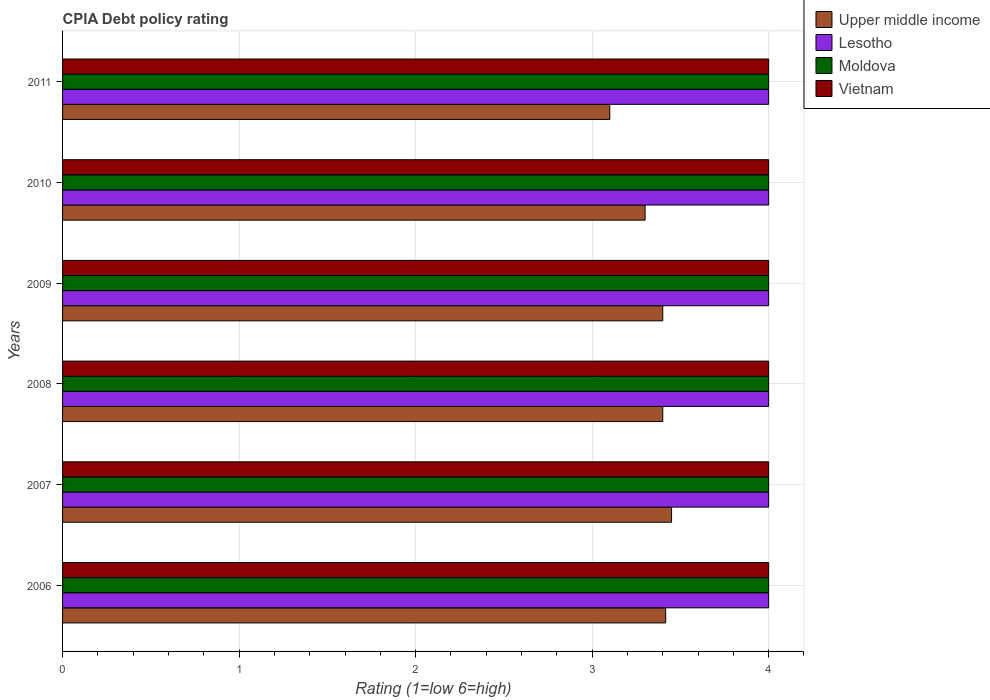How many different coloured bars are there?
Keep it short and to the point. 4. How many bars are there on the 3rd tick from the top?
Give a very brief answer. 4. What is the label of the 5th group of bars from the top?
Your answer should be very brief. 2007. In how many cases, is the number of bars for a given year not equal to the number of legend labels?
Ensure brevity in your answer.  0. What is the CPIA rating in Vietnam in 2008?
Offer a terse response. 4. Across all years, what is the maximum CPIA rating in Vietnam?
Offer a terse response. 4. Across all years, what is the minimum CPIA rating in Moldova?
Keep it short and to the point. 4. In which year was the CPIA rating in Moldova maximum?
Ensure brevity in your answer.  2006. In which year was the CPIA rating in Lesotho minimum?
Give a very brief answer. 2006. What is the total CPIA rating in Moldova in the graph?
Offer a terse response. 24. What is the difference between the CPIA rating in Moldova in 2007 and that in 2008?
Provide a short and direct response. 0. What is the average CPIA rating in Upper middle income per year?
Ensure brevity in your answer.  3.34. In the year 2007, what is the difference between the CPIA rating in Moldova and CPIA rating in Vietnam?
Your response must be concise. 0. In how many years, is the CPIA rating in Upper middle income greater than 1.6 ?
Give a very brief answer. 6. What is the ratio of the CPIA rating in Vietnam in 2008 to that in 2010?
Ensure brevity in your answer.  1. What is the difference between the highest and the second highest CPIA rating in Lesotho?
Make the answer very short. 0. What is the difference between the highest and the lowest CPIA rating in Upper middle income?
Make the answer very short. 0.35. In how many years, is the CPIA rating in Vietnam greater than the average CPIA rating in Vietnam taken over all years?
Give a very brief answer. 0. Is it the case that in every year, the sum of the CPIA rating in Lesotho and CPIA rating in Upper middle income is greater than the sum of CPIA rating in Moldova and CPIA rating in Vietnam?
Offer a terse response. No. What does the 2nd bar from the top in 2008 represents?
Your answer should be compact. Moldova. What does the 4th bar from the bottom in 2009 represents?
Provide a succinct answer. Vietnam. Does the graph contain grids?
Your answer should be very brief. Yes. How many legend labels are there?
Offer a terse response. 4. What is the title of the graph?
Offer a terse response. CPIA Debt policy rating. Does "Heavily indebted poor countries" appear as one of the legend labels in the graph?
Your answer should be compact. No. What is the label or title of the X-axis?
Your answer should be very brief. Rating (1=low 6=high). What is the Rating (1=low 6=high) in Upper middle income in 2006?
Ensure brevity in your answer.  3.42. What is the Rating (1=low 6=high) in Moldova in 2006?
Provide a succinct answer. 4. What is the Rating (1=low 6=high) in Upper middle income in 2007?
Your answer should be compact. 3.45. What is the Rating (1=low 6=high) of Lesotho in 2007?
Offer a terse response. 4. What is the Rating (1=low 6=high) of Lesotho in 2008?
Offer a terse response. 4. What is the Rating (1=low 6=high) in Moldova in 2009?
Ensure brevity in your answer.  4. What is the Rating (1=low 6=high) of Lesotho in 2010?
Offer a very short reply. 4. What is the Rating (1=low 6=high) of Vietnam in 2010?
Your answer should be compact. 4. What is the Rating (1=low 6=high) in Upper middle income in 2011?
Ensure brevity in your answer.  3.1. What is the Rating (1=low 6=high) in Moldova in 2011?
Give a very brief answer. 4. Across all years, what is the maximum Rating (1=low 6=high) of Upper middle income?
Your answer should be compact. 3.45. Across all years, what is the maximum Rating (1=low 6=high) of Vietnam?
Make the answer very short. 4. Across all years, what is the minimum Rating (1=low 6=high) of Upper middle income?
Offer a very short reply. 3.1. Across all years, what is the minimum Rating (1=low 6=high) of Moldova?
Your answer should be very brief. 4. Across all years, what is the minimum Rating (1=low 6=high) of Vietnam?
Offer a very short reply. 4. What is the total Rating (1=low 6=high) in Upper middle income in the graph?
Offer a terse response. 20.07. What is the total Rating (1=low 6=high) of Moldova in the graph?
Your response must be concise. 24. What is the total Rating (1=low 6=high) in Vietnam in the graph?
Offer a very short reply. 24. What is the difference between the Rating (1=low 6=high) of Upper middle income in 2006 and that in 2007?
Offer a terse response. -0.03. What is the difference between the Rating (1=low 6=high) in Lesotho in 2006 and that in 2007?
Keep it short and to the point. 0. What is the difference between the Rating (1=low 6=high) of Moldova in 2006 and that in 2007?
Offer a very short reply. 0. What is the difference between the Rating (1=low 6=high) of Upper middle income in 2006 and that in 2008?
Provide a succinct answer. 0.02. What is the difference between the Rating (1=low 6=high) in Lesotho in 2006 and that in 2008?
Offer a terse response. 0. What is the difference between the Rating (1=low 6=high) of Upper middle income in 2006 and that in 2009?
Your answer should be compact. 0.02. What is the difference between the Rating (1=low 6=high) in Lesotho in 2006 and that in 2009?
Provide a short and direct response. 0. What is the difference between the Rating (1=low 6=high) in Moldova in 2006 and that in 2009?
Ensure brevity in your answer.  0. What is the difference between the Rating (1=low 6=high) of Upper middle income in 2006 and that in 2010?
Make the answer very short. 0.12. What is the difference between the Rating (1=low 6=high) in Lesotho in 2006 and that in 2010?
Give a very brief answer. 0. What is the difference between the Rating (1=low 6=high) of Upper middle income in 2006 and that in 2011?
Provide a succinct answer. 0.32. What is the difference between the Rating (1=low 6=high) of Lesotho in 2006 and that in 2011?
Make the answer very short. 0. What is the difference between the Rating (1=low 6=high) in Upper middle income in 2007 and that in 2008?
Make the answer very short. 0.05. What is the difference between the Rating (1=low 6=high) in Lesotho in 2007 and that in 2008?
Your response must be concise. 0. What is the difference between the Rating (1=low 6=high) of Vietnam in 2007 and that in 2008?
Ensure brevity in your answer.  0. What is the difference between the Rating (1=low 6=high) of Upper middle income in 2007 and that in 2009?
Offer a very short reply. 0.05. What is the difference between the Rating (1=low 6=high) in Vietnam in 2007 and that in 2010?
Offer a terse response. 0. What is the difference between the Rating (1=low 6=high) in Moldova in 2007 and that in 2011?
Offer a very short reply. 0. What is the difference between the Rating (1=low 6=high) in Upper middle income in 2008 and that in 2009?
Ensure brevity in your answer.  0. What is the difference between the Rating (1=low 6=high) in Lesotho in 2008 and that in 2009?
Give a very brief answer. 0. What is the difference between the Rating (1=low 6=high) in Moldova in 2008 and that in 2009?
Your answer should be very brief. 0. What is the difference between the Rating (1=low 6=high) in Vietnam in 2008 and that in 2009?
Offer a very short reply. 0. What is the difference between the Rating (1=low 6=high) in Upper middle income in 2008 and that in 2010?
Give a very brief answer. 0.1. What is the difference between the Rating (1=low 6=high) in Lesotho in 2008 and that in 2010?
Your response must be concise. 0. What is the difference between the Rating (1=low 6=high) of Vietnam in 2008 and that in 2010?
Give a very brief answer. 0. What is the difference between the Rating (1=low 6=high) of Lesotho in 2008 and that in 2011?
Ensure brevity in your answer.  0. What is the difference between the Rating (1=low 6=high) of Upper middle income in 2009 and that in 2010?
Keep it short and to the point. 0.1. What is the difference between the Rating (1=low 6=high) of Lesotho in 2009 and that in 2011?
Make the answer very short. 0. What is the difference between the Rating (1=low 6=high) of Moldova in 2009 and that in 2011?
Provide a succinct answer. 0. What is the difference between the Rating (1=low 6=high) of Upper middle income in 2010 and that in 2011?
Offer a terse response. 0.2. What is the difference between the Rating (1=low 6=high) in Lesotho in 2010 and that in 2011?
Offer a very short reply. 0. What is the difference between the Rating (1=low 6=high) of Moldova in 2010 and that in 2011?
Your answer should be compact. 0. What is the difference between the Rating (1=low 6=high) of Vietnam in 2010 and that in 2011?
Make the answer very short. 0. What is the difference between the Rating (1=low 6=high) in Upper middle income in 2006 and the Rating (1=low 6=high) in Lesotho in 2007?
Keep it short and to the point. -0.58. What is the difference between the Rating (1=low 6=high) of Upper middle income in 2006 and the Rating (1=low 6=high) of Moldova in 2007?
Offer a very short reply. -0.58. What is the difference between the Rating (1=low 6=high) in Upper middle income in 2006 and the Rating (1=low 6=high) in Vietnam in 2007?
Give a very brief answer. -0.58. What is the difference between the Rating (1=low 6=high) in Lesotho in 2006 and the Rating (1=low 6=high) in Moldova in 2007?
Your answer should be compact. 0. What is the difference between the Rating (1=low 6=high) of Lesotho in 2006 and the Rating (1=low 6=high) of Vietnam in 2007?
Your answer should be very brief. 0. What is the difference between the Rating (1=low 6=high) in Upper middle income in 2006 and the Rating (1=low 6=high) in Lesotho in 2008?
Your response must be concise. -0.58. What is the difference between the Rating (1=low 6=high) in Upper middle income in 2006 and the Rating (1=low 6=high) in Moldova in 2008?
Your response must be concise. -0.58. What is the difference between the Rating (1=low 6=high) of Upper middle income in 2006 and the Rating (1=low 6=high) of Vietnam in 2008?
Your answer should be very brief. -0.58. What is the difference between the Rating (1=low 6=high) in Upper middle income in 2006 and the Rating (1=low 6=high) in Lesotho in 2009?
Provide a short and direct response. -0.58. What is the difference between the Rating (1=low 6=high) of Upper middle income in 2006 and the Rating (1=low 6=high) of Moldova in 2009?
Offer a very short reply. -0.58. What is the difference between the Rating (1=low 6=high) of Upper middle income in 2006 and the Rating (1=low 6=high) of Vietnam in 2009?
Give a very brief answer. -0.58. What is the difference between the Rating (1=low 6=high) of Upper middle income in 2006 and the Rating (1=low 6=high) of Lesotho in 2010?
Your response must be concise. -0.58. What is the difference between the Rating (1=low 6=high) of Upper middle income in 2006 and the Rating (1=low 6=high) of Moldova in 2010?
Your response must be concise. -0.58. What is the difference between the Rating (1=low 6=high) of Upper middle income in 2006 and the Rating (1=low 6=high) of Vietnam in 2010?
Give a very brief answer. -0.58. What is the difference between the Rating (1=low 6=high) of Moldova in 2006 and the Rating (1=low 6=high) of Vietnam in 2010?
Make the answer very short. 0. What is the difference between the Rating (1=low 6=high) of Upper middle income in 2006 and the Rating (1=low 6=high) of Lesotho in 2011?
Offer a very short reply. -0.58. What is the difference between the Rating (1=low 6=high) of Upper middle income in 2006 and the Rating (1=low 6=high) of Moldova in 2011?
Offer a terse response. -0.58. What is the difference between the Rating (1=low 6=high) in Upper middle income in 2006 and the Rating (1=low 6=high) in Vietnam in 2011?
Your response must be concise. -0.58. What is the difference between the Rating (1=low 6=high) in Lesotho in 2006 and the Rating (1=low 6=high) in Moldova in 2011?
Your answer should be compact. 0. What is the difference between the Rating (1=low 6=high) of Lesotho in 2006 and the Rating (1=low 6=high) of Vietnam in 2011?
Make the answer very short. 0. What is the difference between the Rating (1=low 6=high) of Moldova in 2006 and the Rating (1=low 6=high) of Vietnam in 2011?
Keep it short and to the point. 0. What is the difference between the Rating (1=low 6=high) of Upper middle income in 2007 and the Rating (1=low 6=high) of Lesotho in 2008?
Provide a short and direct response. -0.55. What is the difference between the Rating (1=low 6=high) in Upper middle income in 2007 and the Rating (1=low 6=high) in Moldova in 2008?
Your response must be concise. -0.55. What is the difference between the Rating (1=low 6=high) in Upper middle income in 2007 and the Rating (1=low 6=high) in Vietnam in 2008?
Ensure brevity in your answer.  -0.55. What is the difference between the Rating (1=low 6=high) of Upper middle income in 2007 and the Rating (1=low 6=high) of Lesotho in 2009?
Your answer should be very brief. -0.55. What is the difference between the Rating (1=low 6=high) in Upper middle income in 2007 and the Rating (1=low 6=high) in Moldova in 2009?
Provide a succinct answer. -0.55. What is the difference between the Rating (1=low 6=high) in Upper middle income in 2007 and the Rating (1=low 6=high) in Vietnam in 2009?
Keep it short and to the point. -0.55. What is the difference between the Rating (1=low 6=high) of Moldova in 2007 and the Rating (1=low 6=high) of Vietnam in 2009?
Provide a succinct answer. 0. What is the difference between the Rating (1=low 6=high) in Upper middle income in 2007 and the Rating (1=low 6=high) in Lesotho in 2010?
Offer a terse response. -0.55. What is the difference between the Rating (1=low 6=high) of Upper middle income in 2007 and the Rating (1=low 6=high) of Moldova in 2010?
Make the answer very short. -0.55. What is the difference between the Rating (1=low 6=high) of Upper middle income in 2007 and the Rating (1=low 6=high) of Vietnam in 2010?
Keep it short and to the point. -0.55. What is the difference between the Rating (1=low 6=high) in Upper middle income in 2007 and the Rating (1=low 6=high) in Lesotho in 2011?
Your response must be concise. -0.55. What is the difference between the Rating (1=low 6=high) in Upper middle income in 2007 and the Rating (1=low 6=high) in Moldova in 2011?
Provide a succinct answer. -0.55. What is the difference between the Rating (1=low 6=high) in Upper middle income in 2007 and the Rating (1=low 6=high) in Vietnam in 2011?
Your answer should be very brief. -0.55. What is the difference between the Rating (1=low 6=high) in Lesotho in 2007 and the Rating (1=low 6=high) in Moldova in 2011?
Keep it short and to the point. 0. What is the difference between the Rating (1=low 6=high) of Upper middle income in 2008 and the Rating (1=low 6=high) of Moldova in 2009?
Keep it short and to the point. -0.6. What is the difference between the Rating (1=low 6=high) of Upper middle income in 2008 and the Rating (1=low 6=high) of Vietnam in 2009?
Offer a very short reply. -0.6. What is the difference between the Rating (1=low 6=high) of Lesotho in 2008 and the Rating (1=low 6=high) of Moldova in 2009?
Provide a short and direct response. 0. What is the difference between the Rating (1=low 6=high) in Upper middle income in 2008 and the Rating (1=low 6=high) in Moldova in 2010?
Give a very brief answer. -0.6. What is the difference between the Rating (1=low 6=high) in Lesotho in 2008 and the Rating (1=low 6=high) in Moldova in 2010?
Give a very brief answer. 0. What is the difference between the Rating (1=low 6=high) of Lesotho in 2008 and the Rating (1=low 6=high) of Vietnam in 2010?
Keep it short and to the point. 0. What is the difference between the Rating (1=low 6=high) of Upper middle income in 2008 and the Rating (1=low 6=high) of Moldova in 2011?
Ensure brevity in your answer.  -0.6. What is the difference between the Rating (1=low 6=high) of Upper middle income in 2008 and the Rating (1=low 6=high) of Vietnam in 2011?
Your response must be concise. -0.6. What is the difference between the Rating (1=low 6=high) of Lesotho in 2008 and the Rating (1=low 6=high) of Moldova in 2011?
Make the answer very short. 0. What is the difference between the Rating (1=low 6=high) in Lesotho in 2008 and the Rating (1=low 6=high) in Vietnam in 2011?
Your answer should be very brief. 0. What is the difference between the Rating (1=low 6=high) of Upper middle income in 2009 and the Rating (1=low 6=high) of Vietnam in 2010?
Your response must be concise. -0.6. What is the difference between the Rating (1=low 6=high) in Lesotho in 2009 and the Rating (1=low 6=high) in Moldova in 2010?
Offer a very short reply. 0. What is the difference between the Rating (1=low 6=high) in Lesotho in 2009 and the Rating (1=low 6=high) in Vietnam in 2010?
Your response must be concise. 0. What is the difference between the Rating (1=low 6=high) of Moldova in 2009 and the Rating (1=low 6=high) of Vietnam in 2010?
Ensure brevity in your answer.  0. What is the difference between the Rating (1=low 6=high) in Upper middle income in 2009 and the Rating (1=low 6=high) in Vietnam in 2011?
Ensure brevity in your answer.  -0.6. What is the difference between the Rating (1=low 6=high) in Lesotho in 2009 and the Rating (1=low 6=high) in Moldova in 2011?
Make the answer very short. 0. What is the difference between the Rating (1=low 6=high) of Moldova in 2009 and the Rating (1=low 6=high) of Vietnam in 2011?
Offer a terse response. 0. What is the difference between the Rating (1=low 6=high) of Lesotho in 2010 and the Rating (1=low 6=high) of Vietnam in 2011?
Give a very brief answer. 0. What is the average Rating (1=low 6=high) in Upper middle income per year?
Offer a terse response. 3.34. What is the average Rating (1=low 6=high) of Moldova per year?
Make the answer very short. 4. What is the average Rating (1=low 6=high) of Vietnam per year?
Ensure brevity in your answer.  4. In the year 2006, what is the difference between the Rating (1=low 6=high) in Upper middle income and Rating (1=low 6=high) in Lesotho?
Offer a terse response. -0.58. In the year 2006, what is the difference between the Rating (1=low 6=high) of Upper middle income and Rating (1=low 6=high) of Moldova?
Your response must be concise. -0.58. In the year 2006, what is the difference between the Rating (1=low 6=high) in Upper middle income and Rating (1=low 6=high) in Vietnam?
Offer a terse response. -0.58. In the year 2006, what is the difference between the Rating (1=low 6=high) of Lesotho and Rating (1=low 6=high) of Moldova?
Offer a very short reply. 0. In the year 2007, what is the difference between the Rating (1=low 6=high) of Upper middle income and Rating (1=low 6=high) of Lesotho?
Provide a succinct answer. -0.55. In the year 2007, what is the difference between the Rating (1=low 6=high) of Upper middle income and Rating (1=low 6=high) of Moldova?
Provide a short and direct response. -0.55. In the year 2007, what is the difference between the Rating (1=low 6=high) of Upper middle income and Rating (1=low 6=high) of Vietnam?
Keep it short and to the point. -0.55. In the year 2008, what is the difference between the Rating (1=low 6=high) of Upper middle income and Rating (1=low 6=high) of Lesotho?
Offer a terse response. -0.6. In the year 2008, what is the difference between the Rating (1=low 6=high) of Upper middle income and Rating (1=low 6=high) of Vietnam?
Make the answer very short. -0.6. In the year 2008, what is the difference between the Rating (1=low 6=high) of Lesotho and Rating (1=low 6=high) of Vietnam?
Offer a terse response. 0. In the year 2008, what is the difference between the Rating (1=low 6=high) in Moldova and Rating (1=low 6=high) in Vietnam?
Provide a short and direct response. 0. In the year 2009, what is the difference between the Rating (1=low 6=high) in Lesotho and Rating (1=low 6=high) in Moldova?
Ensure brevity in your answer.  0. In the year 2010, what is the difference between the Rating (1=low 6=high) of Moldova and Rating (1=low 6=high) of Vietnam?
Your answer should be compact. 0. In the year 2011, what is the difference between the Rating (1=low 6=high) in Upper middle income and Rating (1=low 6=high) in Lesotho?
Make the answer very short. -0.9. In the year 2011, what is the difference between the Rating (1=low 6=high) of Upper middle income and Rating (1=low 6=high) of Moldova?
Provide a succinct answer. -0.9. In the year 2011, what is the difference between the Rating (1=low 6=high) in Upper middle income and Rating (1=low 6=high) in Vietnam?
Your response must be concise. -0.9. In the year 2011, what is the difference between the Rating (1=low 6=high) of Lesotho and Rating (1=low 6=high) of Moldova?
Your response must be concise. 0. What is the ratio of the Rating (1=low 6=high) in Upper middle income in 2006 to that in 2007?
Ensure brevity in your answer.  0.99. What is the ratio of the Rating (1=low 6=high) in Lesotho in 2006 to that in 2007?
Your answer should be very brief. 1. What is the ratio of the Rating (1=low 6=high) of Moldova in 2006 to that in 2007?
Your response must be concise. 1. What is the ratio of the Rating (1=low 6=high) of Vietnam in 2006 to that in 2007?
Give a very brief answer. 1. What is the ratio of the Rating (1=low 6=high) in Upper middle income in 2006 to that in 2008?
Your response must be concise. 1. What is the ratio of the Rating (1=low 6=high) in Moldova in 2006 to that in 2009?
Provide a short and direct response. 1. What is the ratio of the Rating (1=low 6=high) in Vietnam in 2006 to that in 2009?
Give a very brief answer. 1. What is the ratio of the Rating (1=low 6=high) in Upper middle income in 2006 to that in 2010?
Your answer should be very brief. 1.04. What is the ratio of the Rating (1=low 6=high) in Moldova in 2006 to that in 2010?
Provide a short and direct response. 1. What is the ratio of the Rating (1=low 6=high) of Upper middle income in 2006 to that in 2011?
Your response must be concise. 1.1. What is the ratio of the Rating (1=low 6=high) of Upper middle income in 2007 to that in 2008?
Give a very brief answer. 1.01. What is the ratio of the Rating (1=low 6=high) of Moldova in 2007 to that in 2008?
Keep it short and to the point. 1. What is the ratio of the Rating (1=low 6=high) of Vietnam in 2007 to that in 2008?
Offer a terse response. 1. What is the ratio of the Rating (1=low 6=high) in Upper middle income in 2007 to that in 2009?
Make the answer very short. 1.01. What is the ratio of the Rating (1=low 6=high) in Lesotho in 2007 to that in 2009?
Provide a succinct answer. 1. What is the ratio of the Rating (1=low 6=high) in Moldova in 2007 to that in 2009?
Your answer should be compact. 1. What is the ratio of the Rating (1=low 6=high) of Vietnam in 2007 to that in 2009?
Your response must be concise. 1. What is the ratio of the Rating (1=low 6=high) of Upper middle income in 2007 to that in 2010?
Your response must be concise. 1.05. What is the ratio of the Rating (1=low 6=high) in Moldova in 2007 to that in 2010?
Your answer should be very brief. 1. What is the ratio of the Rating (1=low 6=high) of Upper middle income in 2007 to that in 2011?
Make the answer very short. 1.11. What is the ratio of the Rating (1=low 6=high) in Moldova in 2007 to that in 2011?
Provide a short and direct response. 1. What is the ratio of the Rating (1=low 6=high) of Vietnam in 2007 to that in 2011?
Ensure brevity in your answer.  1. What is the ratio of the Rating (1=low 6=high) of Upper middle income in 2008 to that in 2009?
Your answer should be very brief. 1. What is the ratio of the Rating (1=low 6=high) in Upper middle income in 2008 to that in 2010?
Offer a terse response. 1.03. What is the ratio of the Rating (1=low 6=high) in Lesotho in 2008 to that in 2010?
Make the answer very short. 1. What is the ratio of the Rating (1=low 6=high) in Moldova in 2008 to that in 2010?
Keep it short and to the point. 1. What is the ratio of the Rating (1=low 6=high) in Vietnam in 2008 to that in 2010?
Provide a succinct answer. 1. What is the ratio of the Rating (1=low 6=high) in Upper middle income in 2008 to that in 2011?
Provide a short and direct response. 1.1. What is the ratio of the Rating (1=low 6=high) in Lesotho in 2008 to that in 2011?
Offer a very short reply. 1. What is the ratio of the Rating (1=low 6=high) of Vietnam in 2008 to that in 2011?
Your response must be concise. 1. What is the ratio of the Rating (1=low 6=high) in Upper middle income in 2009 to that in 2010?
Offer a very short reply. 1.03. What is the ratio of the Rating (1=low 6=high) in Moldova in 2009 to that in 2010?
Your response must be concise. 1. What is the ratio of the Rating (1=low 6=high) of Vietnam in 2009 to that in 2010?
Your response must be concise. 1. What is the ratio of the Rating (1=low 6=high) in Upper middle income in 2009 to that in 2011?
Offer a terse response. 1.1. What is the ratio of the Rating (1=low 6=high) in Upper middle income in 2010 to that in 2011?
Offer a terse response. 1.06. What is the ratio of the Rating (1=low 6=high) of Lesotho in 2010 to that in 2011?
Your answer should be very brief. 1. What is the ratio of the Rating (1=low 6=high) in Moldova in 2010 to that in 2011?
Offer a terse response. 1. What is the ratio of the Rating (1=low 6=high) in Vietnam in 2010 to that in 2011?
Offer a very short reply. 1. What is the difference between the highest and the second highest Rating (1=low 6=high) of Lesotho?
Your response must be concise. 0. What is the difference between the highest and the second highest Rating (1=low 6=high) in Vietnam?
Provide a succinct answer. 0. What is the difference between the highest and the lowest Rating (1=low 6=high) of Upper middle income?
Keep it short and to the point. 0.35. What is the difference between the highest and the lowest Rating (1=low 6=high) of Lesotho?
Provide a short and direct response. 0. What is the difference between the highest and the lowest Rating (1=low 6=high) in Moldova?
Your answer should be compact. 0. What is the difference between the highest and the lowest Rating (1=low 6=high) of Vietnam?
Your answer should be very brief. 0. 